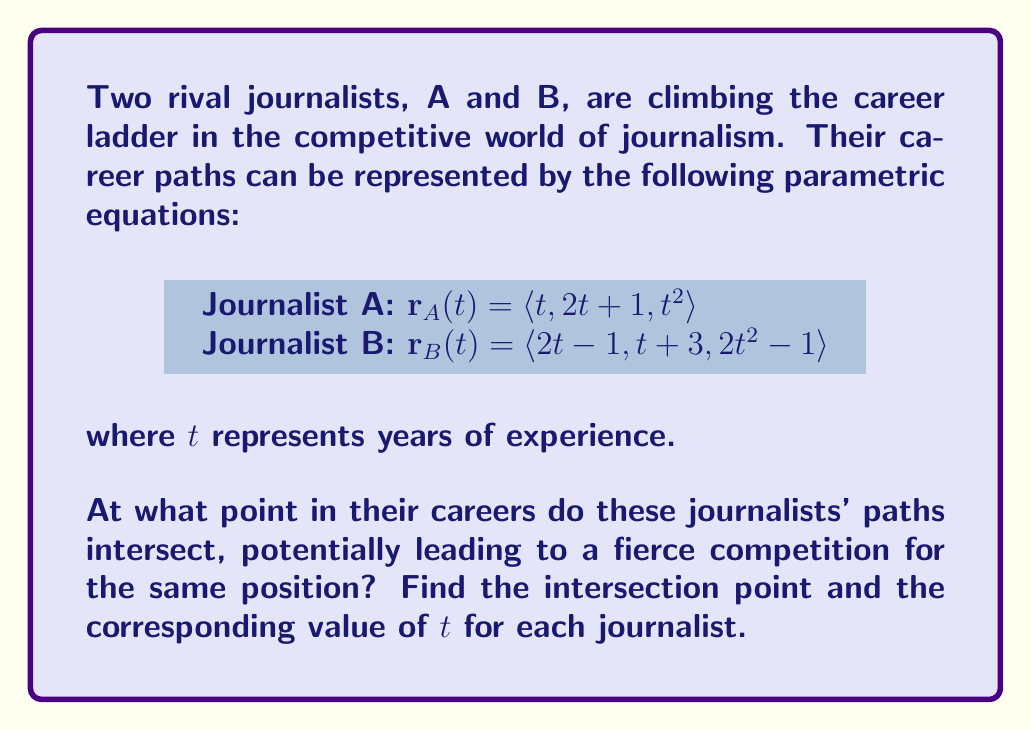Teach me how to tackle this problem. To find the intersection point, we need to equate the corresponding components of the two parametric equations:

1) First component: $t = 2t-1$
2) Second component: $2t+1 = t+3$
3) Third component: $t^2 = 2t^2-1$

Let's solve these equations step by step:

1) From the first equation:
   $t = 2t-1$
   $1 = t$
   So, $t_A = 1$ for Journalist A

2) Substitute this into the second equation to find $t_B$:
   $2(1)+1 = t_B+3$
   $3 = t_B+3$
   $t_B = 0$

3) Verify using the third equation:
   For $t_A = 1$: $1^2 = 1$
   For $t_B = 0$: $2(0)^2-1 = -1$
   $1 = -1$ (This doesn't match)

This means there is no intersection point that satisfies all three equations simultaneously.

To find the point of closest approach, we can substitute the found $t$ values into their respective equations:

For Journalist A ($t_A = 1$):
$\mathbf{r}_A(1) = \langle 1, 3, 1 \rangle$

For Journalist B ($t_B = 0$):
$\mathbf{r}_B(0) = \langle -1, 3, -1 \rangle$

The midpoint of these two points can be considered as the point of closest approach:

$\text{Midpoint} = \left(\frac{1+(-1)}{2}, \frac{3+3}{2}, \frac{1+(-1)}{2}\right) = (0, 3, 0)$

This point represents the closest their career paths come to intersecting.
Answer: No intersection. Closest approach: $(0, 3, 0)$ at $t_A = 1$, $t_B = 0$. 